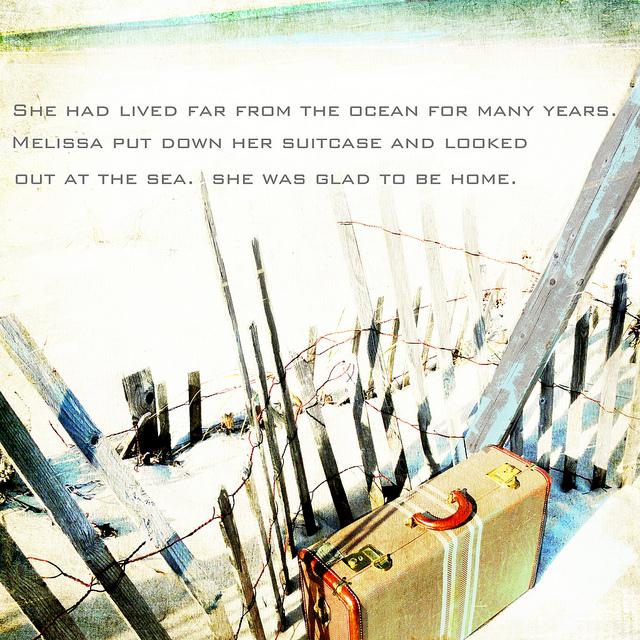What color is the suitcase's handle?
Concise answer only. Red. Is the suitcase open?
Concise answer only. No. According to the text, who does the suitcase belong to?
Answer briefly. Melissa. 